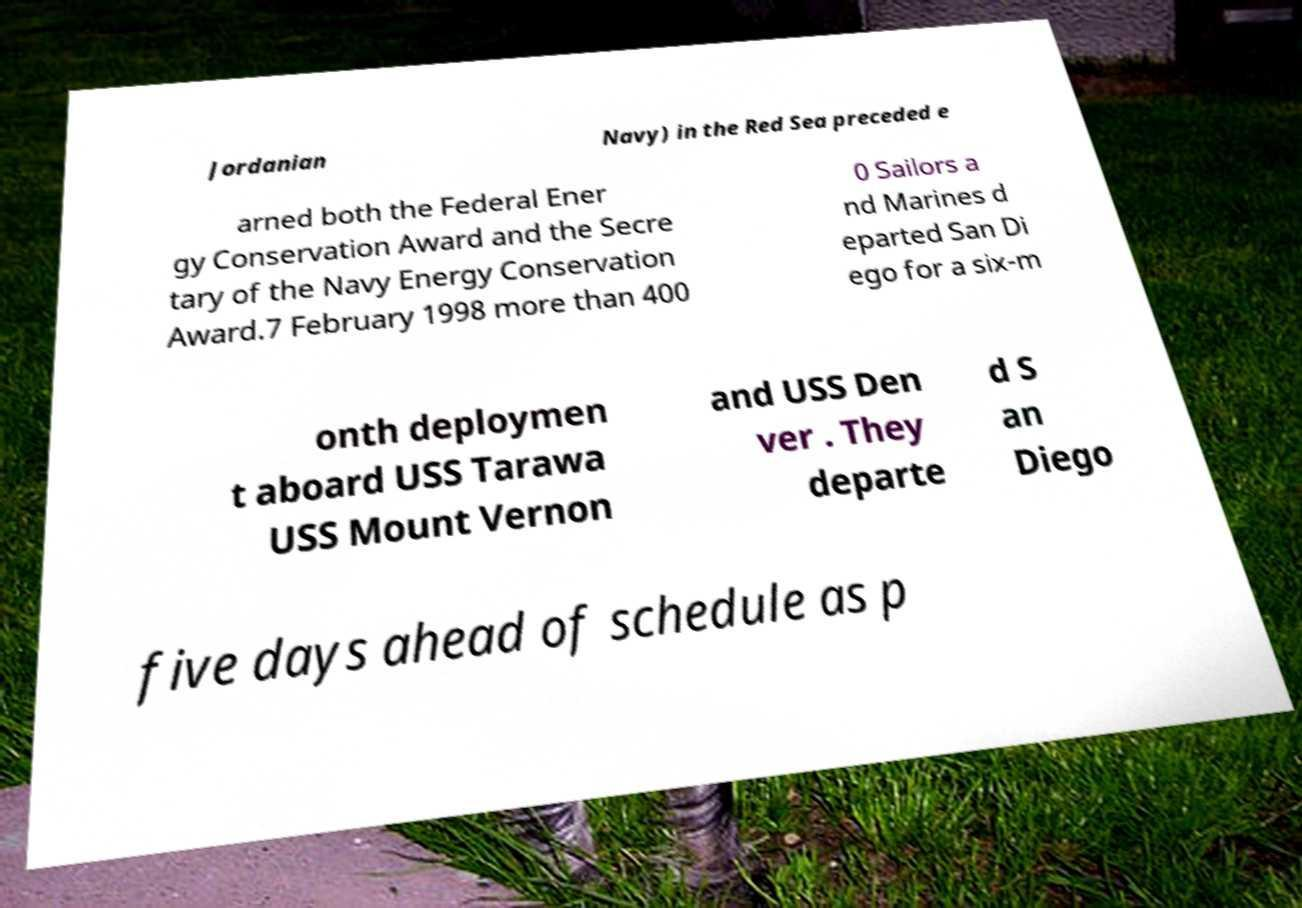What messages or text are displayed in this image? I need them in a readable, typed format. Jordanian Navy) in the Red Sea preceded e arned both the Federal Ener gy Conservation Award and the Secre tary of the Navy Energy Conservation Award.7 February 1998 more than 400 0 Sailors a nd Marines d eparted San Di ego for a six-m onth deploymen t aboard USS Tarawa USS Mount Vernon and USS Den ver . They departe d S an Diego five days ahead of schedule as p 